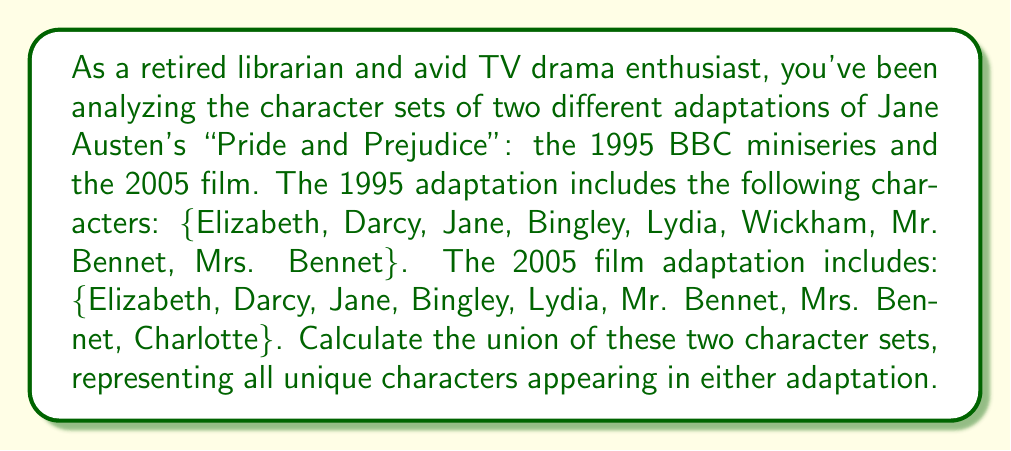Provide a solution to this math problem. To solve this problem, we need to understand the concept of union in set theory. The union of two sets A and B, denoted as $A \cup B$, is the set of all elements that are in A, or in B, or in both A and B.

Let's define our sets:
Set A (1995 adaptation): $A = \{Elizabeth, Darcy, Jane, Bingley, Lydia, Wickham, Mr. Bennet, Mrs. Bennet\}$
Set B (2005 adaptation): $B = \{Elizabeth, Darcy, Jane, Bingley, Lydia, Mr. Bennet, Mrs. Bennet, Charlotte\}$

To find the union, we list all unique elements from both sets:

1. Start with all elements from Set A.
2. Add any elements from Set B that are not already in the union set.

The resulting union set will contain:
1. All characters from Set A: Elizabeth, Darcy, Jane, Bingley, Lydia, Wickham, Mr. Bennet, Mrs. Bennet
2. The additional character from Set B not in Set A: Charlotte

Therefore, the union of the two character sets is:
$$A \cup B = \{Elizabeth, Darcy, Jane, Bingley, Lydia, Wickham, Mr. Bennet, Mrs. Bennet, Charlotte\}$$

This set contains 9 unique characters in total.
Answer: $A \cup B = \{Elizabeth, Darcy, Jane, Bingley, Lydia, Wickham, Mr. Bennet, Mrs. Bennet, Charlotte\}$ 